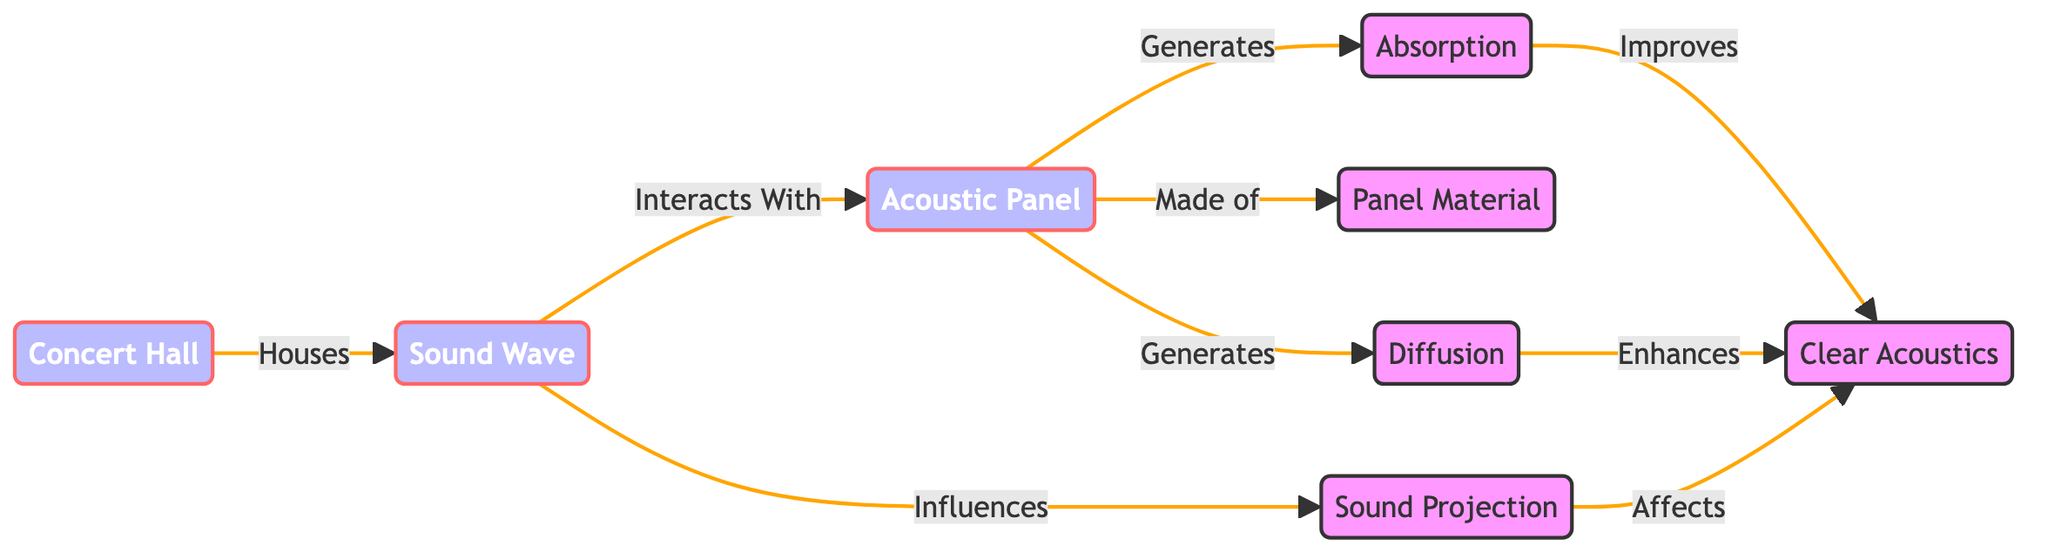What does a concert hall house? The diagram indicates that the concert hall is the primary structure that houses sound waves, as shown by the arrow pointing from the concert hall to the sound wave node.
Answer: Sound wave What influences sound projection? According to the diagram, sound waves have a direct influence on sound projection, as indicated by the arrow from the sound wave node to the sound projection node.
Answer: Sound waves How many main elements are shown in the diagram? The main elements represented in the diagram include the concert hall, sound wave, sound projection, acoustic panel, panel material, absorption, diffusion, and clear acoustics. Counting these nodes gives a total of seven.
Answer: Seven What does an acoustic panel generate? The diagram shows arrows coming from the acoustic panel indicating that it generates both absorption and diffusion, shown by the two outputs leading to their respective nodes.
Answer: Absorption and diffusion What improves clear acoustics? The diagram outlines that both absorption and diffusion contribute to improving clear acoustics, as both nodes have arrows pointing to the clear acoustics node.
Answer: Absorption and diffusion What is an acoustic panel made of? The diagram specifies that the acoustic panel is made of panel material, with a direct connection indicated by the arrow from the acoustic panel to the panel material node.
Answer: Panel material Which element affects clear acoustics? The diagram indicates that sound projection affects clear acoustics, as signified by the arrow from sound projection pointing to the clear acoustics node.
Answer: Sound projection How does sound wave interact with an acoustic panel? The diagram indicates that sound waves interact with acoustic panels, which is shown by the direct interaction arrow leading from the sound wave node to the acoustic panel node.
Answer: Interacts What role does diffusion play in the context of clear acoustics? According to the diagram, diffusion enhances clear acoustics, as indicated by the arrow pointing from the diffusion node to the clear acoustics node.
Answer: Enhances 